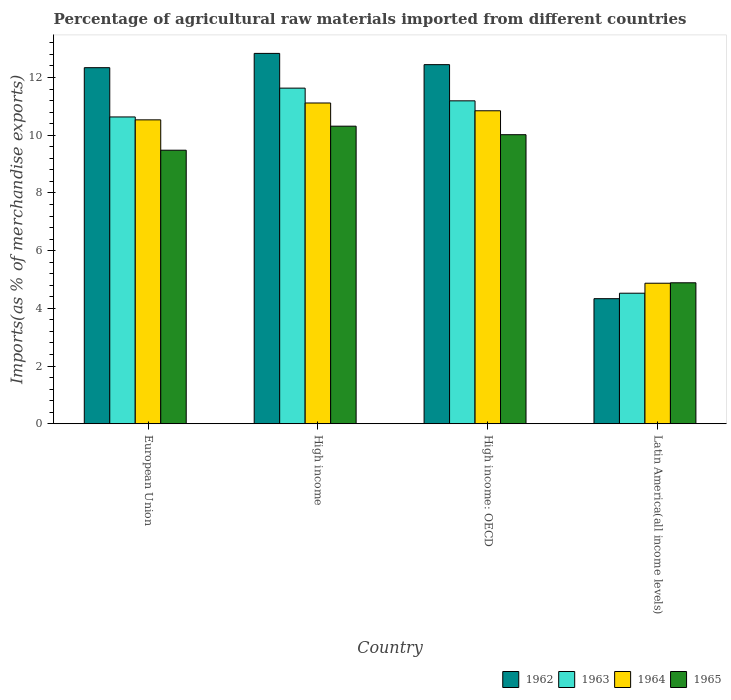Are the number of bars on each tick of the X-axis equal?
Ensure brevity in your answer.  Yes. What is the label of the 3rd group of bars from the left?
Your answer should be very brief. High income: OECD. In how many cases, is the number of bars for a given country not equal to the number of legend labels?
Your answer should be compact. 0. What is the percentage of imports to different countries in 1963 in Latin America(all income levels)?
Make the answer very short. 4.52. Across all countries, what is the maximum percentage of imports to different countries in 1962?
Offer a terse response. 12.84. Across all countries, what is the minimum percentage of imports to different countries in 1965?
Give a very brief answer. 4.89. In which country was the percentage of imports to different countries in 1963 minimum?
Provide a short and direct response. Latin America(all income levels). What is the total percentage of imports to different countries in 1962 in the graph?
Provide a short and direct response. 41.96. What is the difference between the percentage of imports to different countries in 1963 in European Union and that in High income?
Offer a terse response. -1. What is the difference between the percentage of imports to different countries in 1964 in Latin America(all income levels) and the percentage of imports to different countries in 1963 in European Union?
Provide a succinct answer. -5.76. What is the average percentage of imports to different countries in 1964 per country?
Provide a succinct answer. 9.34. What is the difference between the percentage of imports to different countries of/in 1962 and percentage of imports to different countries of/in 1963 in High income?
Keep it short and to the point. 1.2. In how many countries, is the percentage of imports to different countries in 1962 greater than 7.2 %?
Offer a very short reply. 3. What is the ratio of the percentage of imports to different countries in 1963 in High income to that in High income: OECD?
Give a very brief answer. 1.04. What is the difference between the highest and the second highest percentage of imports to different countries in 1965?
Your answer should be compact. -0.83. What is the difference between the highest and the lowest percentage of imports to different countries in 1964?
Keep it short and to the point. 6.25. In how many countries, is the percentage of imports to different countries in 1962 greater than the average percentage of imports to different countries in 1962 taken over all countries?
Make the answer very short. 3. What does the 2nd bar from the left in High income represents?
Your response must be concise. 1963. What does the 3rd bar from the right in High income represents?
Keep it short and to the point. 1963. Is it the case that in every country, the sum of the percentage of imports to different countries in 1965 and percentage of imports to different countries in 1962 is greater than the percentage of imports to different countries in 1963?
Your response must be concise. Yes. How many bars are there?
Offer a terse response. 16. Are all the bars in the graph horizontal?
Provide a succinct answer. No. How many countries are there in the graph?
Provide a short and direct response. 4. Does the graph contain any zero values?
Make the answer very short. No. Does the graph contain grids?
Offer a very short reply. No. Where does the legend appear in the graph?
Your answer should be very brief. Bottom right. How many legend labels are there?
Your response must be concise. 4. What is the title of the graph?
Provide a succinct answer. Percentage of agricultural raw materials imported from different countries. What is the label or title of the X-axis?
Keep it short and to the point. Country. What is the label or title of the Y-axis?
Give a very brief answer. Imports(as % of merchandise exports). What is the Imports(as % of merchandise exports) in 1962 in European Union?
Your answer should be very brief. 12.34. What is the Imports(as % of merchandise exports) in 1963 in European Union?
Offer a terse response. 10.63. What is the Imports(as % of merchandise exports) in 1964 in European Union?
Give a very brief answer. 10.53. What is the Imports(as % of merchandise exports) of 1965 in European Union?
Make the answer very short. 9.48. What is the Imports(as % of merchandise exports) in 1962 in High income?
Offer a very short reply. 12.84. What is the Imports(as % of merchandise exports) of 1963 in High income?
Your answer should be very brief. 11.63. What is the Imports(as % of merchandise exports) in 1964 in High income?
Ensure brevity in your answer.  11.12. What is the Imports(as % of merchandise exports) in 1965 in High income?
Provide a short and direct response. 10.31. What is the Imports(as % of merchandise exports) of 1962 in High income: OECD?
Your answer should be very brief. 12.45. What is the Imports(as % of merchandise exports) of 1963 in High income: OECD?
Give a very brief answer. 11.19. What is the Imports(as % of merchandise exports) in 1964 in High income: OECD?
Your answer should be compact. 10.85. What is the Imports(as % of merchandise exports) of 1965 in High income: OECD?
Your answer should be compact. 10.02. What is the Imports(as % of merchandise exports) of 1962 in Latin America(all income levels)?
Your response must be concise. 4.33. What is the Imports(as % of merchandise exports) of 1963 in Latin America(all income levels)?
Keep it short and to the point. 4.52. What is the Imports(as % of merchandise exports) in 1964 in Latin America(all income levels)?
Provide a succinct answer. 4.87. What is the Imports(as % of merchandise exports) in 1965 in Latin America(all income levels)?
Ensure brevity in your answer.  4.89. Across all countries, what is the maximum Imports(as % of merchandise exports) in 1962?
Provide a succinct answer. 12.84. Across all countries, what is the maximum Imports(as % of merchandise exports) of 1963?
Your response must be concise. 11.63. Across all countries, what is the maximum Imports(as % of merchandise exports) in 1964?
Give a very brief answer. 11.12. Across all countries, what is the maximum Imports(as % of merchandise exports) of 1965?
Offer a very short reply. 10.31. Across all countries, what is the minimum Imports(as % of merchandise exports) in 1962?
Your response must be concise. 4.33. Across all countries, what is the minimum Imports(as % of merchandise exports) of 1963?
Your answer should be very brief. 4.52. Across all countries, what is the minimum Imports(as % of merchandise exports) of 1964?
Make the answer very short. 4.87. Across all countries, what is the minimum Imports(as % of merchandise exports) in 1965?
Your response must be concise. 4.89. What is the total Imports(as % of merchandise exports) in 1962 in the graph?
Your answer should be compact. 41.96. What is the total Imports(as % of merchandise exports) in 1963 in the graph?
Your response must be concise. 37.98. What is the total Imports(as % of merchandise exports) of 1964 in the graph?
Provide a short and direct response. 37.37. What is the total Imports(as % of merchandise exports) of 1965 in the graph?
Provide a succinct answer. 34.7. What is the difference between the Imports(as % of merchandise exports) of 1962 in European Union and that in High income?
Offer a terse response. -0.5. What is the difference between the Imports(as % of merchandise exports) of 1963 in European Union and that in High income?
Your answer should be compact. -1. What is the difference between the Imports(as % of merchandise exports) of 1964 in European Union and that in High income?
Provide a short and direct response. -0.58. What is the difference between the Imports(as % of merchandise exports) in 1965 in European Union and that in High income?
Offer a very short reply. -0.83. What is the difference between the Imports(as % of merchandise exports) of 1962 in European Union and that in High income: OECD?
Provide a short and direct response. -0.11. What is the difference between the Imports(as % of merchandise exports) in 1963 in European Union and that in High income: OECD?
Keep it short and to the point. -0.56. What is the difference between the Imports(as % of merchandise exports) in 1964 in European Union and that in High income: OECD?
Offer a very short reply. -0.31. What is the difference between the Imports(as % of merchandise exports) in 1965 in European Union and that in High income: OECD?
Keep it short and to the point. -0.54. What is the difference between the Imports(as % of merchandise exports) in 1962 in European Union and that in Latin America(all income levels)?
Provide a succinct answer. 8.01. What is the difference between the Imports(as % of merchandise exports) in 1963 in European Union and that in Latin America(all income levels)?
Provide a succinct answer. 6.11. What is the difference between the Imports(as % of merchandise exports) of 1964 in European Union and that in Latin America(all income levels)?
Your answer should be compact. 5.66. What is the difference between the Imports(as % of merchandise exports) of 1965 in European Union and that in Latin America(all income levels)?
Provide a short and direct response. 4.59. What is the difference between the Imports(as % of merchandise exports) in 1962 in High income and that in High income: OECD?
Your answer should be very brief. 0.39. What is the difference between the Imports(as % of merchandise exports) of 1963 in High income and that in High income: OECD?
Keep it short and to the point. 0.44. What is the difference between the Imports(as % of merchandise exports) of 1964 in High income and that in High income: OECD?
Give a very brief answer. 0.27. What is the difference between the Imports(as % of merchandise exports) in 1965 in High income and that in High income: OECD?
Ensure brevity in your answer.  0.3. What is the difference between the Imports(as % of merchandise exports) of 1962 in High income and that in Latin America(all income levels)?
Offer a terse response. 8.5. What is the difference between the Imports(as % of merchandise exports) in 1963 in High income and that in Latin America(all income levels)?
Your answer should be compact. 7.11. What is the difference between the Imports(as % of merchandise exports) of 1964 in High income and that in Latin America(all income levels)?
Keep it short and to the point. 6.25. What is the difference between the Imports(as % of merchandise exports) in 1965 in High income and that in Latin America(all income levels)?
Make the answer very short. 5.43. What is the difference between the Imports(as % of merchandise exports) of 1962 in High income: OECD and that in Latin America(all income levels)?
Your answer should be compact. 8.11. What is the difference between the Imports(as % of merchandise exports) of 1963 in High income: OECD and that in Latin America(all income levels)?
Provide a short and direct response. 6.67. What is the difference between the Imports(as % of merchandise exports) in 1964 in High income: OECD and that in Latin America(all income levels)?
Give a very brief answer. 5.98. What is the difference between the Imports(as % of merchandise exports) in 1965 in High income: OECD and that in Latin America(all income levels)?
Your answer should be very brief. 5.13. What is the difference between the Imports(as % of merchandise exports) of 1962 in European Union and the Imports(as % of merchandise exports) of 1963 in High income?
Your answer should be compact. 0.71. What is the difference between the Imports(as % of merchandise exports) in 1962 in European Union and the Imports(as % of merchandise exports) in 1964 in High income?
Make the answer very short. 1.22. What is the difference between the Imports(as % of merchandise exports) in 1962 in European Union and the Imports(as % of merchandise exports) in 1965 in High income?
Provide a short and direct response. 2.03. What is the difference between the Imports(as % of merchandise exports) of 1963 in European Union and the Imports(as % of merchandise exports) of 1964 in High income?
Give a very brief answer. -0.48. What is the difference between the Imports(as % of merchandise exports) in 1963 in European Union and the Imports(as % of merchandise exports) in 1965 in High income?
Keep it short and to the point. 0.32. What is the difference between the Imports(as % of merchandise exports) in 1964 in European Union and the Imports(as % of merchandise exports) in 1965 in High income?
Provide a short and direct response. 0.22. What is the difference between the Imports(as % of merchandise exports) in 1962 in European Union and the Imports(as % of merchandise exports) in 1963 in High income: OECD?
Make the answer very short. 1.15. What is the difference between the Imports(as % of merchandise exports) in 1962 in European Union and the Imports(as % of merchandise exports) in 1964 in High income: OECD?
Ensure brevity in your answer.  1.49. What is the difference between the Imports(as % of merchandise exports) in 1962 in European Union and the Imports(as % of merchandise exports) in 1965 in High income: OECD?
Provide a short and direct response. 2.32. What is the difference between the Imports(as % of merchandise exports) of 1963 in European Union and the Imports(as % of merchandise exports) of 1964 in High income: OECD?
Make the answer very short. -0.21. What is the difference between the Imports(as % of merchandise exports) in 1963 in European Union and the Imports(as % of merchandise exports) in 1965 in High income: OECD?
Offer a terse response. 0.62. What is the difference between the Imports(as % of merchandise exports) in 1964 in European Union and the Imports(as % of merchandise exports) in 1965 in High income: OECD?
Keep it short and to the point. 0.51. What is the difference between the Imports(as % of merchandise exports) in 1962 in European Union and the Imports(as % of merchandise exports) in 1963 in Latin America(all income levels)?
Make the answer very short. 7.82. What is the difference between the Imports(as % of merchandise exports) of 1962 in European Union and the Imports(as % of merchandise exports) of 1964 in Latin America(all income levels)?
Make the answer very short. 7.47. What is the difference between the Imports(as % of merchandise exports) of 1962 in European Union and the Imports(as % of merchandise exports) of 1965 in Latin America(all income levels)?
Your answer should be compact. 7.46. What is the difference between the Imports(as % of merchandise exports) of 1963 in European Union and the Imports(as % of merchandise exports) of 1964 in Latin America(all income levels)?
Offer a terse response. 5.76. What is the difference between the Imports(as % of merchandise exports) in 1963 in European Union and the Imports(as % of merchandise exports) in 1965 in Latin America(all income levels)?
Provide a succinct answer. 5.75. What is the difference between the Imports(as % of merchandise exports) of 1964 in European Union and the Imports(as % of merchandise exports) of 1965 in Latin America(all income levels)?
Your response must be concise. 5.65. What is the difference between the Imports(as % of merchandise exports) in 1962 in High income and the Imports(as % of merchandise exports) in 1963 in High income: OECD?
Your answer should be very brief. 1.64. What is the difference between the Imports(as % of merchandise exports) of 1962 in High income and the Imports(as % of merchandise exports) of 1964 in High income: OECD?
Keep it short and to the point. 1.99. What is the difference between the Imports(as % of merchandise exports) in 1962 in High income and the Imports(as % of merchandise exports) in 1965 in High income: OECD?
Provide a succinct answer. 2.82. What is the difference between the Imports(as % of merchandise exports) of 1963 in High income and the Imports(as % of merchandise exports) of 1964 in High income: OECD?
Offer a terse response. 0.78. What is the difference between the Imports(as % of merchandise exports) in 1963 in High income and the Imports(as % of merchandise exports) in 1965 in High income: OECD?
Provide a short and direct response. 1.61. What is the difference between the Imports(as % of merchandise exports) of 1964 in High income and the Imports(as % of merchandise exports) of 1965 in High income: OECD?
Your response must be concise. 1.1. What is the difference between the Imports(as % of merchandise exports) in 1962 in High income and the Imports(as % of merchandise exports) in 1963 in Latin America(all income levels)?
Offer a terse response. 8.31. What is the difference between the Imports(as % of merchandise exports) of 1962 in High income and the Imports(as % of merchandise exports) of 1964 in Latin America(all income levels)?
Your answer should be compact. 7.97. What is the difference between the Imports(as % of merchandise exports) in 1962 in High income and the Imports(as % of merchandise exports) in 1965 in Latin America(all income levels)?
Your answer should be compact. 7.95. What is the difference between the Imports(as % of merchandise exports) of 1963 in High income and the Imports(as % of merchandise exports) of 1964 in Latin America(all income levels)?
Provide a short and direct response. 6.76. What is the difference between the Imports(as % of merchandise exports) in 1963 in High income and the Imports(as % of merchandise exports) in 1965 in Latin America(all income levels)?
Provide a short and direct response. 6.75. What is the difference between the Imports(as % of merchandise exports) of 1964 in High income and the Imports(as % of merchandise exports) of 1965 in Latin America(all income levels)?
Your answer should be very brief. 6.23. What is the difference between the Imports(as % of merchandise exports) in 1962 in High income: OECD and the Imports(as % of merchandise exports) in 1963 in Latin America(all income levels)?
Your answer should be compact. 7.92. What is the difference between the Imports(as % of merchandise exports) in 1962 in High income: OECD and the Imports(as % of merchandise exports) in 1964 in Latin America(all income levels)?
Offer a very short reply. 7.58. What is the difference between the Imports(as % of merchandise exports) of 1962 in High income: OECD and the Imports(as % of merchandise exports) of 1965 in Latin America(all income levels)?
Provide a short and direct response. 7.56. What is the difference between the Imports(as % of merchandise exports) in 1963 in High income: OECD and the Imports(as % of merchandise exports) in 1964 in Latin America(all income levels)?
Make the answer very short. 6.32. What is the difference between the Imports(as % of merchandise exports) in 1963 in High income: OECD and the Imports(as % of merchandise exports) in 1965 in Latin America(all income levels)?
Your answer should be compact. 6.31. What is the difference between the Imports(as % of merchandise exports) of 1964 in High income: OECD and the Imports(as % of merchandise exports) of 1965 in Latin America(all income levels)?
Keep it short and to the point. 5.96. What is the average Imports(as % of merchandise exports) in 1962 per country?
Your answer should be compact. 10.49. What is the average Imports(as % of merchandise exports) of 1963 per country?
Your answer should be very brief. 9.5. What is the average Imports(as % of merchandise exports) of 1964 per country?
Your response must be concise. 9.34. What is the average Imports(as % of merchandise exports) in 1965 per country?
Your response must be concise. 8.67. What is the difference between the Imports(as % of merchandise exports) in 1962 and Imports(as % of merchandise exports) in 1963 in European Union?
Your answer should be very brief. 1.71. What is the difference between the Imports(as % of merchandise exports) in 1962 and Imports(as % of merchandise exports) in 1964 in European Union?
Provide a succinct answer. 1.81. What is the difference between the Imports(as % of merchandise exports) in 1962 and Imports(as % of merchandise exports) in 1965 in European Union?
Make the answer very short. 2.86. What is the difference between the Imports(as % of merchandise exports) of 1963 and Imports(as % of merchandise exports) of 1964 in European Union?
Ensure brevity in your answer.  0.1. What is the difference between the Imports(as % of merchandise exports) in 1963 and Imports(as % of merchandise exports) in 1965 in European Union?
Provide a short and direct response. 1.15. What is the difference between the Imports(as % of merchandise exports) in 1964 and Imports(as % of merchandise exports) in 1965 in European Union?
Keep it short and to the point. 1.05. What is the difference between the Imports(as % of merchandise exports) of 1962 and Imports(as % of merchandise exports) of 1963 in High income?
Provide a short and direct response. 1.2. What is the difference between the Imports(as % of merchandise exports) of 1962 and Imports(as % of merchandise exports) of 1964 in High income?
Provide a succinct answer. 1.72. What is the difference between the Imports(as % of merchandise exports) in 1962 and Imports(as % of merchandise exports) in 1965 in High income?
Your answer should be compact. 2.52. What is the difference between the Imports(as % of merchandise exports) in 1963 and Imports(as % of merchandise exports) in 1964 in High income?
Your answer should be very brief. 0.52. What is the difference between the Imports(as % of merchandise exports) in 1963 and Imports(as % of merchandise exports) in 1965 in High income?
Your answer should be very brief. 1.32. What is the difference between the Imports(as % of merchandise exports) in 1964 and Imports(as % of merchandise exports) in 1965 in High income?
Keep it short and to the point. 0.8. What is the difference between the Imports(as % of merchandise exports) in 1962 and Imports(as % of merchandise exports) in 1963 in High income: OECD?
Provide a short and direct response. 1.25. What is the difference between the Imports(as % of merchandise exports) of 1962 and Imports(as % of merchandise exports) of 1964 in High income: OECD?
Make the answer very short. 1.6. What is the difference between the Imports(as % of merchandise exports) of 1962 and Imports(as % of merchandise exports) of 1965 in High income: OECD?
Provide a short and direct response. 2.43. What is the difference between the Imports(as % of merchandise exports) of 1963 and Imports(as % of merchandise exports) of 1964 in High income: OECD?
Provide a succinct answer. 0.34. What is the difference between the Imports(as % of merchandise exports) of 1963 and Imports(as % of merchandise exports) of 1965 in High income: OECD?
Give a very brief answer. 1.17. What is the difference between the Imports(as % of merchandise exports) of 1964 and Imports(as % of merchandise exports) of 1965 in High income: OECD?
Ensure brevity in your answer.  0.83. What is the difference between the Imports(as % of merchandise exports) in 1962 and Imports(as % of merchandise exports) in 1963 in Latin America(all income levels)?
Your answer should be compact. -0.19. What is the difference between the Imports(as % of merchandise exports) in 1962 and Imports(as % of merchandise exports) in 1964 in Latin America(all income levels)?
Provide a succinct answer. -0.54. What is the difference between the Imports(as % of merchandise exports) of 1962 and Imports(as % of merchandise exports) of 1965 in Latin America(all income levels)?
Keep it short and to the point. -0.55. What is the difference between the Imports(as % of merchandise exports) in 1963 and Imports(as % of merchandise exports) in 1964 in Latin America(all income levels)?
Give a very brief answer. -0.35. What is the difference between the Imports(as % of merchandise exports) of 1963 and Imports(as % of merchandise exports) of 1965 in Latin America(all income levels)?
Offer a terse response. -0.36. What is the difference between the Imports(as % of merchandise exports) in 1964 and Imports(as % of merchandise exports) in 1965 in Latin America(all income levels)?
Your response must be concise. -0.02. What is the ratio of the Imports(as % of merchandise exports) in 1962 in European Union to that in High income?
Provide a succinct answer. 0.96. What is the ratio of the Imports(as % of merchandise exports) of 1963 in European Union to that in High income?
Your response must be concise. 0.91. What is the ratio of the Imports(as % of merchandise exports) of 1964 in European Union to that in High income?
Make the answer very short. 0.95. What is the ratio of the Imports(as % of merchandise exports) in 1965 in European Union to that in High income?
Your answer should be very brief. 0.92. What is the ratio of the Imports(as % of merchandise exports) in 1962 in European Union to that in High income: OECD?
Offer a very short reply. 0.99. What is the ratio of the Imports(as % of merchandise exports) in 1963 in European Union to that in High income: OECD?
Offer a very short reply. 0.95. What is the ratio of the Imports(as % of merchandise exports) in 1965 in European Union to that in High income: OECD?
Offer a terse response. 0.95. What is the ratio of the Imports(as % of merchandise exports) in 1962 in European Union to that in Latin America(all income levels)?
Make the answer very short. 2.85. What is the ratio of the Imports(as % of merchandise exports) in 1963 in European Union to that in Latin America(all income levels)?
Give a very brief answer. 2.35. What is the ratio of the Imports(as % of merchandise exports) of 1964 in European Union to that in Latin America(all income levels)?
Make the answer very short. 2.16. What is the ratio of the Imports(as % of merchandise exports) of 1965 in European Union to that in Latin America(all income levels)?
Your response must be concise. 1.94. What is the ratio of the Imports(as % of merchandise exports) of 1962 in High income to that in High income: OECD?
Give a very brief answer. 1.03. What is the ratio of the Imports(as % of merchandise exports) of 1963 in High income to that in High income: OECD?
Give a very brief answer. 1.04. What is the ratio of the Imports(as % of merchandise exports) in 1964 in High income to that in High income: OECD?
Provide a succinct answer. 1.02. What is the ratio of the Imports(as % of merchandise exports) in 1965 in High income to that in High income: OECD?
Make the answer very short. 1.03. What is the ratio of the Imports(as % of merchandise exports) in 1962 in High income to that in Latin America(all income levels)?
Offer a terse response. 2.96. What is the ratio of the Imports(as % of merchandise exports) of 1963 in High income to that in Latin America(all income levels)?
Your response must be concise. 2.57. What is the ratio of the Imports(as % of merchandise exports) in 1964 in High income to that in Latin America(all income levels)?
Keep it short and to the point. 2.28. What is the ratio of the Imports(as % of merchandise exports) in 1965 in High income to that in Latin America(all income levels)?
Your answer should be compact. 2.11. What is the ratio of the Imports(as % of merchandise exports) in 1962 in High income: OECD to that in Latin America(all income levels)?
Offer a very short reply. 2.87. What is the ratio of the Imports(as % of merchandise exports) of 1963 in High income: OECD to that in Latin America(all income levels)?
Your answer should be very brief. 2.47. What is the ratio of the Imports(as % of merchandise exports) of 1964 in High income: OECD to that in Latin America(all income levels)?
Your response must be concise. 2.23. What is the ratio of the Imports(as % of merchandise exports) of 1965 in High income: OECD to that in Latin America(all income levels)?
Keep it short and to the point. 2.05. What is the difference between the highest and the second highest Imports(as % of merchandise exports) in 1962?
Offer a very short reply. 0.39. What is the difference between the highest and the second highest Imports(as % of merchandise exports) of 1963?
Offer a terse response. 0.44. What is the difference between the highest and the second highest Imports(as % of merchandise exports) in 1964?
Offer a very short reply. 0.27. What is the difference between the highest and the second highest Imports(as % of merchandise exports) in 1965?
Make the answer very short. 0.3. What is the difference between the highest and the lowest Imports(as % of merchandise exports) of 1962?
Provide a short and direct response. 8.5. What is the difference between the highest and the lowest Imports(as % of merchandise exports) of 1963?
Keep it short and to the point. 7.11. What is the difference between the highest and the lowest Imports(as % of merchandise exports) of 1964?
Your answer should be very brief. 6.25. What is the difference between the highest and the lowest Imports(as % of merchandise exports) in 1965?
Your response must be concise. 5.43. 